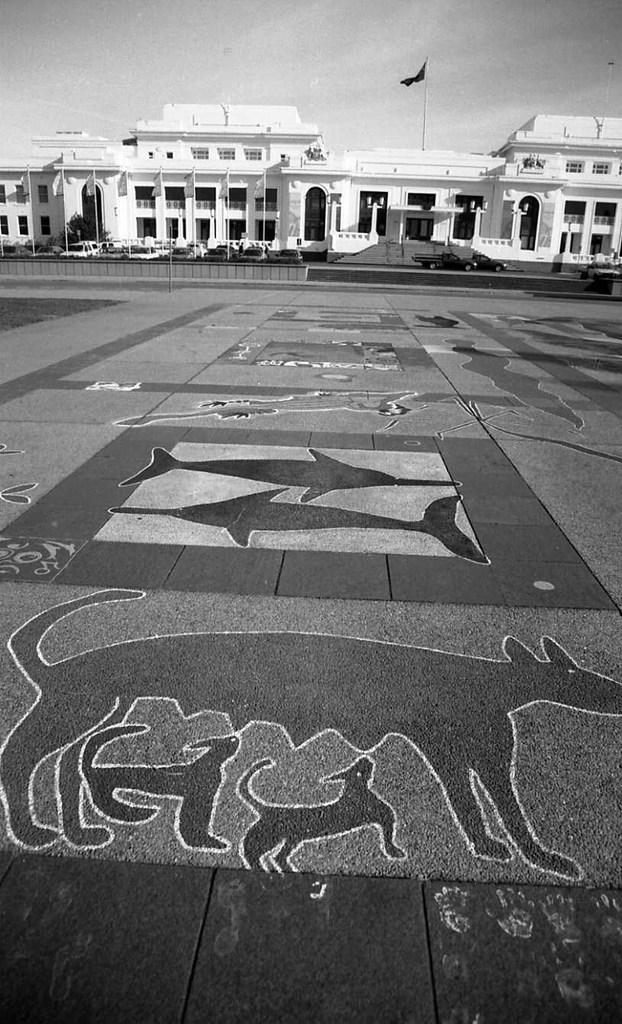What type of structure is visible in the image? There is a building in the image. What is flying near the building? There is a flag in the image. What can be seen moving on the ground in the image? There are vehicles on the road in the image. What is the design on the ground in the image? The ground has a design in the image. What is visible above the building and vehicles in the image? The sky is visible at the top of the image. Where is the jail located in the image? There is no jail present in the image. What type of bedroom can be seen in the image? There is no bedroom present in the image. 